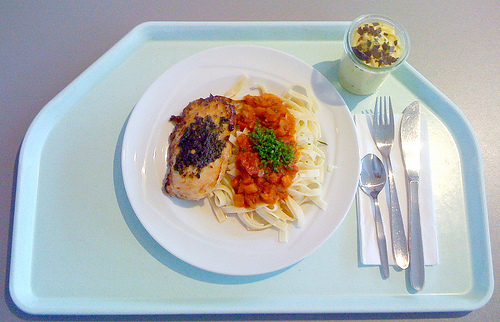<image>
Is the garnish on the pasta? Yes. Looking at the image, I can see the garnish is positioned on top of the pasta, with the pasta providing support. Is the chicken on the tray? Yes. Looking at the image, I can see the chicken is positioned on top of the tray, with the tray providing support. 